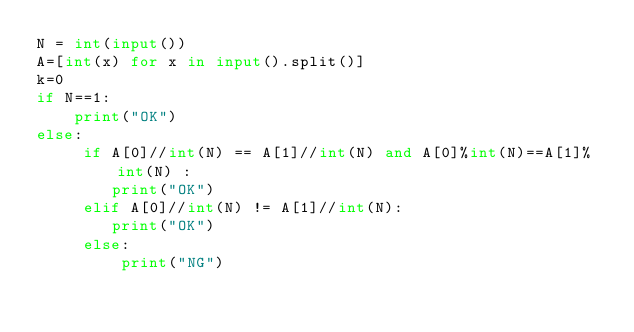<code> <loc_0><loc_0><loc_500><loc_500><_Python_>N = int(input())
A=[int(x) for x in input().split()]
k=0
if N==1:
    print("OK")
else:
     if A[0]//int(N) == A[1]//int(N) and A[0]%int(N)==A[1]%int(N) :
        print("OK")
     elif A[0]//int(N) != A[1]//int(N):
        print("OK")
     else:
         print("NG")</code> 